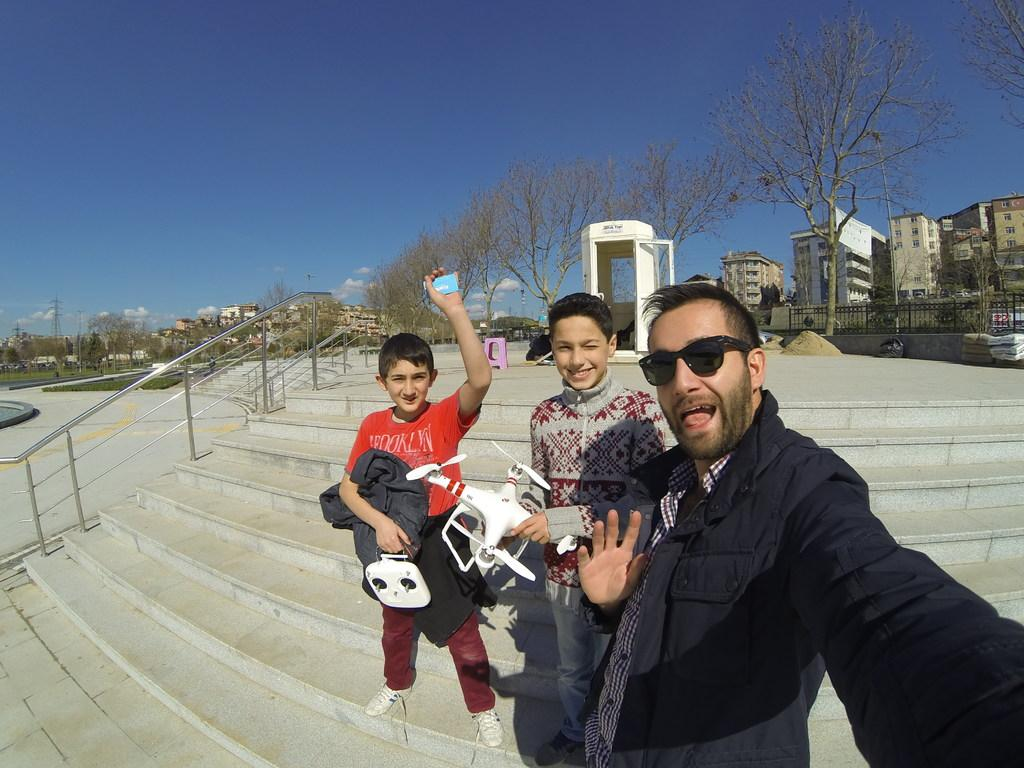Who or what can be seen in the image? There are people in the image. What architectural feature is present in the image? There are stairs in the image. What safety feature is present near the stairs? There are railings in the image. What can be seen in the distance in the image? There are buildings, trees, and the sky visible in the background of the image. What type of notebook is being used by the people in the image? There is no notebook present in the image. What kind of wheel can be seen on the side of the building in the image? There is no wheel visible on any building in the image. 